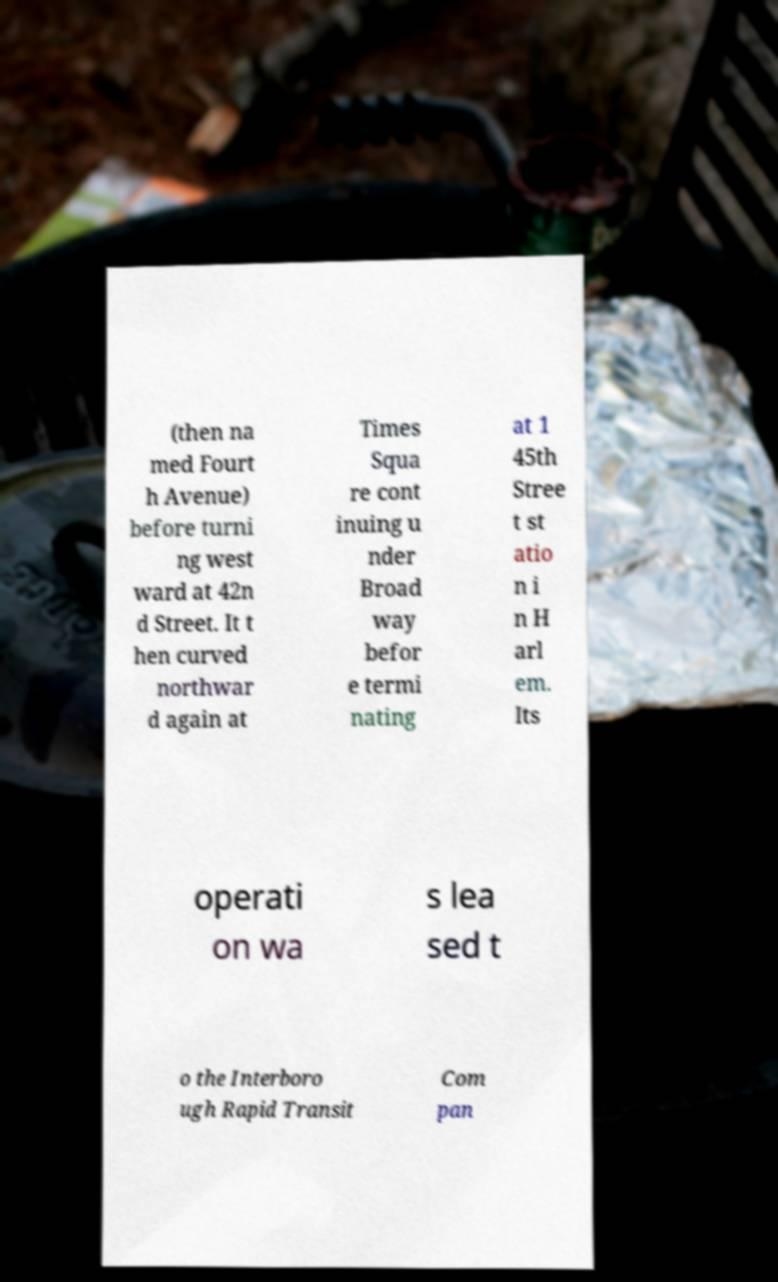Can you accurately transcribe the text from the provided image for me? (then na med Fourt h Avenue) before turni ng west ward at 42n d Street. It t hen curved northwar d again at Times Squa re cont inuing u nder Broad way befor e termi nating at 1 45th Stree t st atio n i n H arl em. Its operati on wa s lea sed t o the Interboro ugh Rapid Transit Com pan 